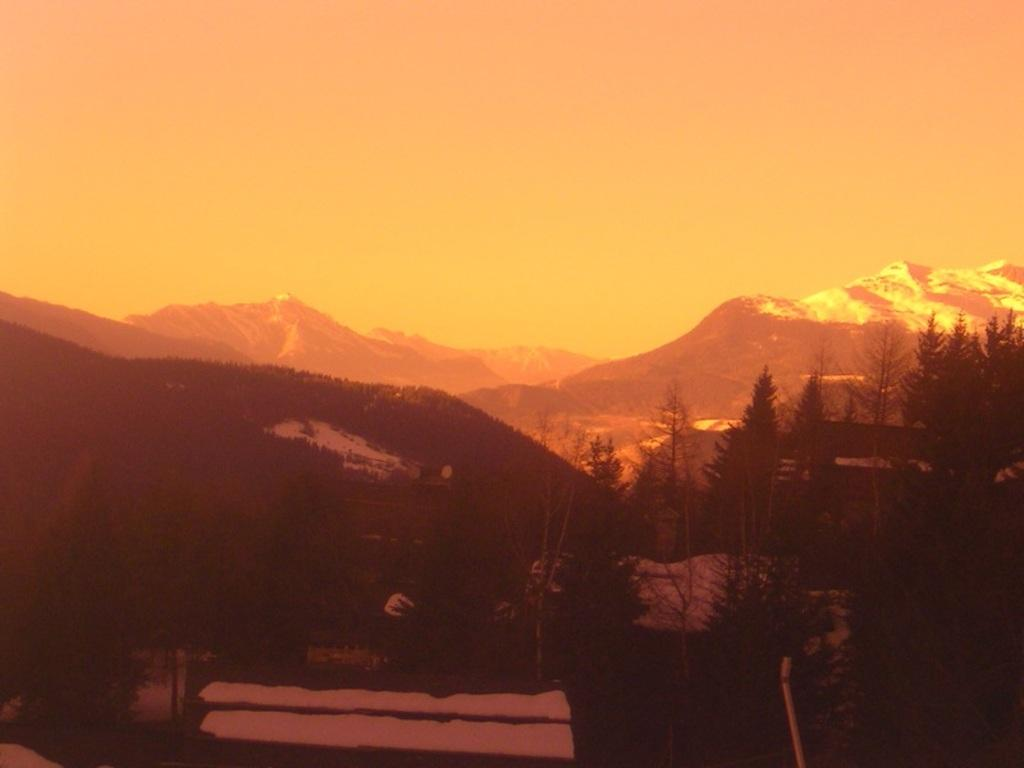What type of vegetation can be seen in the image? There are trees in the image. What type of landscape feature is present in the image? There are hills in the image. What is visible at the top of the image? The sky is visible at the top of the image. How many fingers can be seen pointing at the trees in the image? There are no fingers visible in the image, as it features trees, hills, and the sky. What type of liquid is being poured from a soda can in the image? There is no soda can or liquid present in the image; it only contains trees, hills, and the sky. 